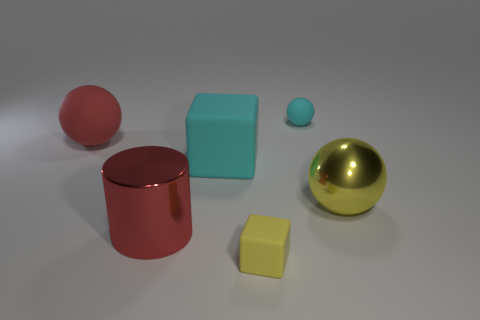Add 2 large cyan cubes. How many objects exist? 8 Subtract all blocks. How many objects are left? 4 Subtract 0 gray balls. How many objects are left? 6 Subtract all red shiny cylinders. Subtract all tiny cyan matte spheres. How many objects are left? 4 Add 4 cylinders. How many cylinders are left? 5 Add 5 green objects. How many green objects exist? 5 